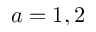<formula> <loc_0><loc_0><loc_500><loc_500>a = 1 , 2</formula> 